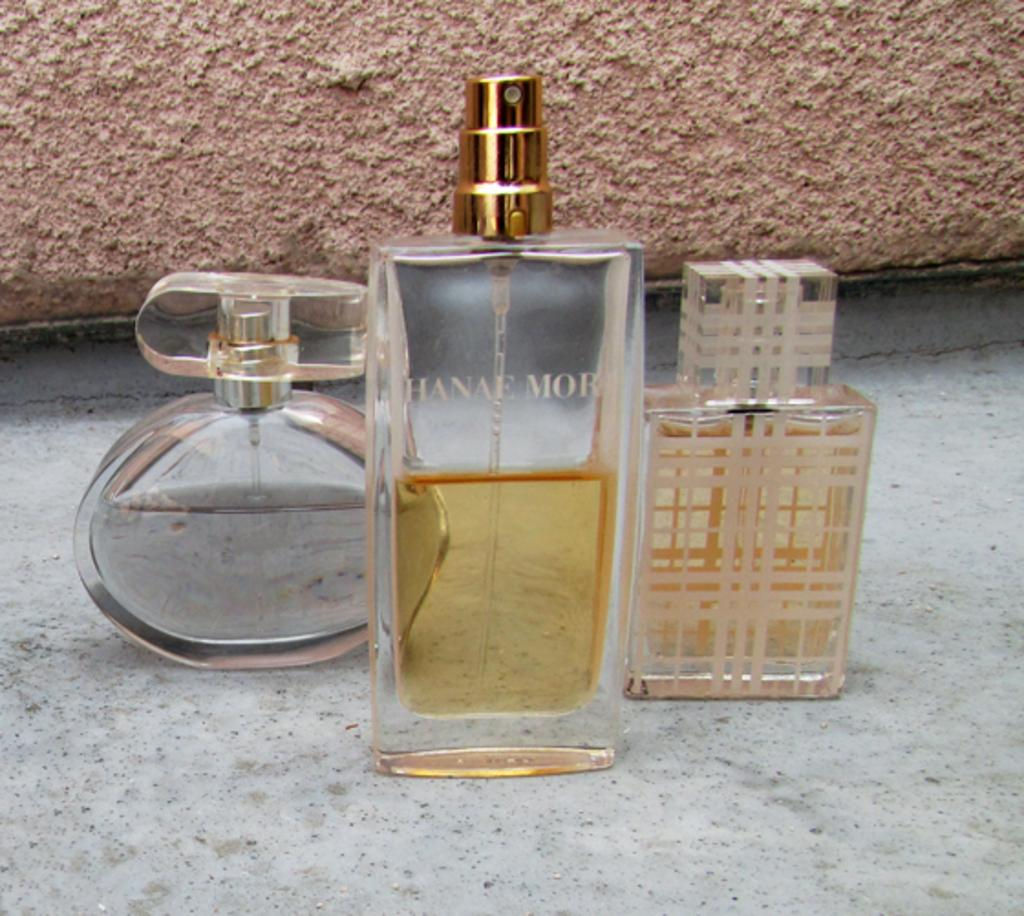Provide a one-sentence caption for the provided image. three bottles of perfume on a marble floor including Hanae MOR. 